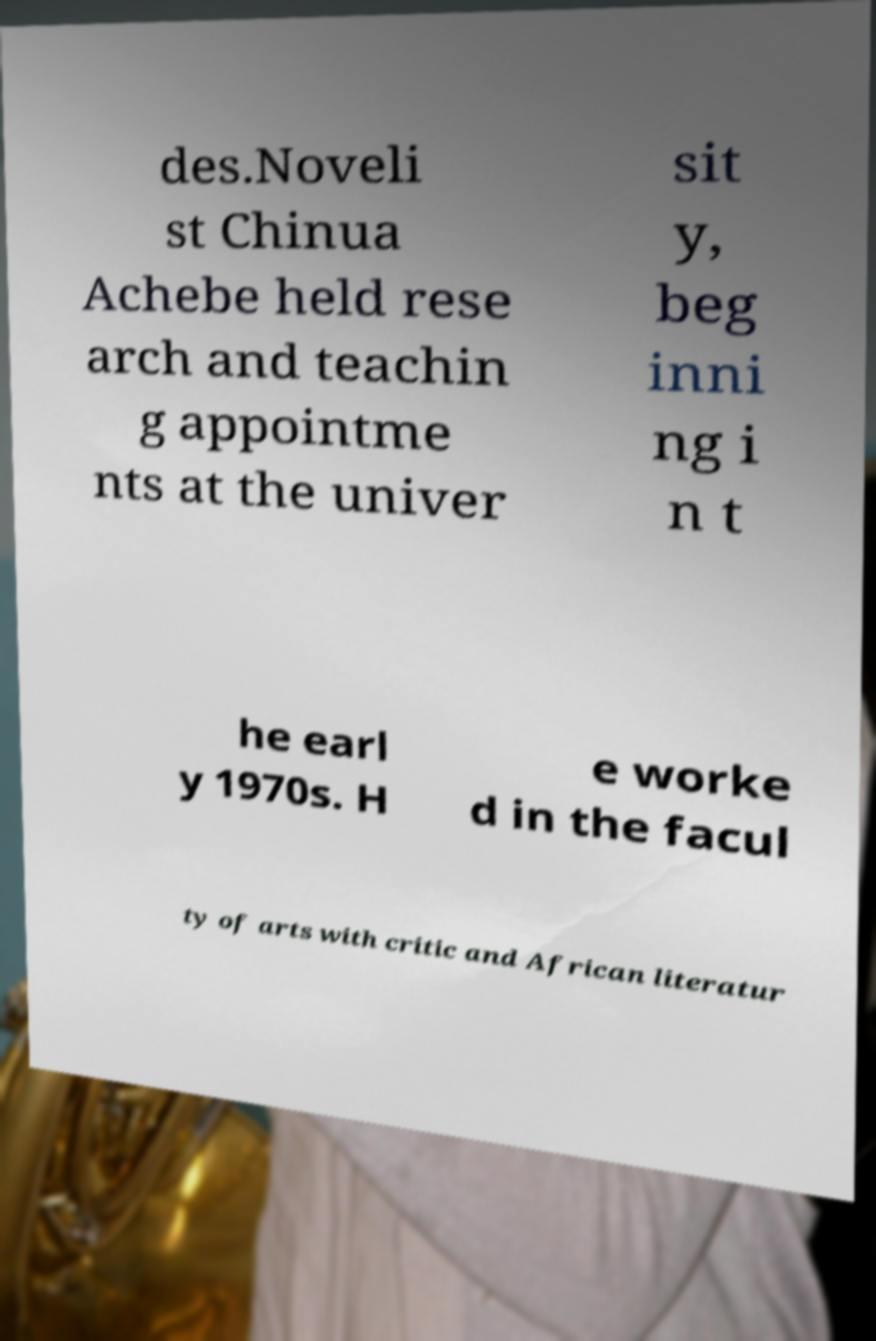There's text embedded in this image that I need extracted. Can you transcribe it verbatim? des.Noveli st Chinua Achebe held rese arch and teachin g appointme nts at the univer sit y, beg inni ng i n t he earl y 1970s. H e worke d in the facul ty of arts with critic and African literatur 